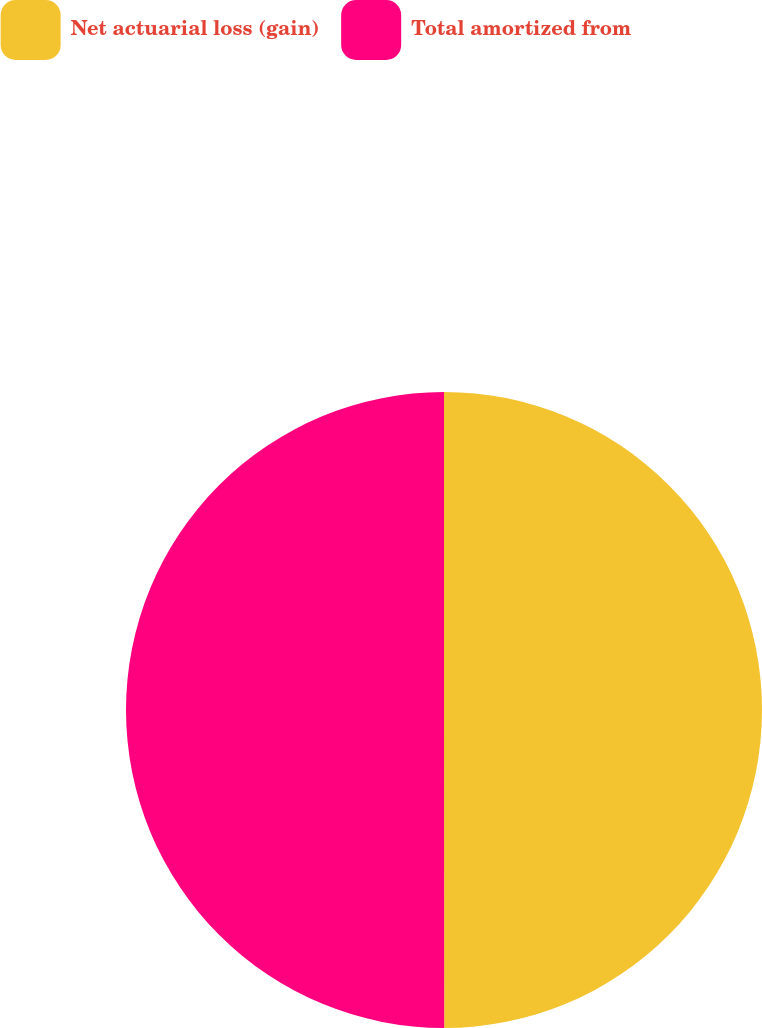Convert chart. <chart><loc_0><loc_0><loc_500><loc_500><pie_chart><fcel>Net actuarial loss (gain)<fcel>Total amortized from<nl><fcel>49.99%<fcel>50.01%<nl></chart> 